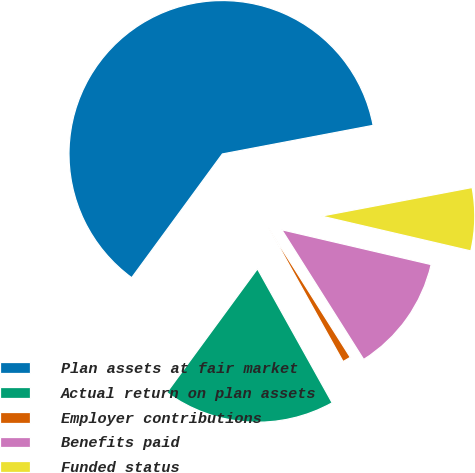<chart> <loc_0><loc_0><loc_500><loc_500><pie_chart><fcel>Plan assets at fair market<fcel>Actual return on plan assets<fcel>Employer contributions<fcel>Benefits paid<fcel>Funded status<nl><fcel>61.95%<fcel>18.16%<fcel>0.87%<fcel>12.39%<fcel>6.63%<nl></chart> 